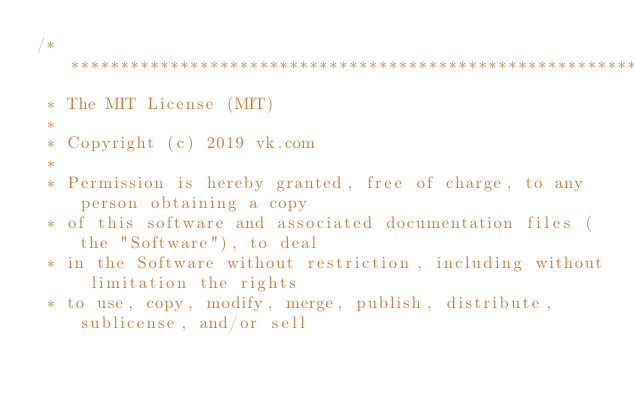<code> <loc_0><loc_0><loc_500><loc_500><_Kotlin_>/*******************************************************************************
 * The MIT License (MIT)
 *
 * Copyright (c) 2019 vk.com
 *
 * Permission is hereby granted, free of charge, to any person obtaining a copy
 * of this software and associated documentation files (the "Software"), to deal
 * in the Software without restriction, including without limitation the rights
 * to use, copy, modify, merge, publish, distribute, sublicense, and/or sell</code> 